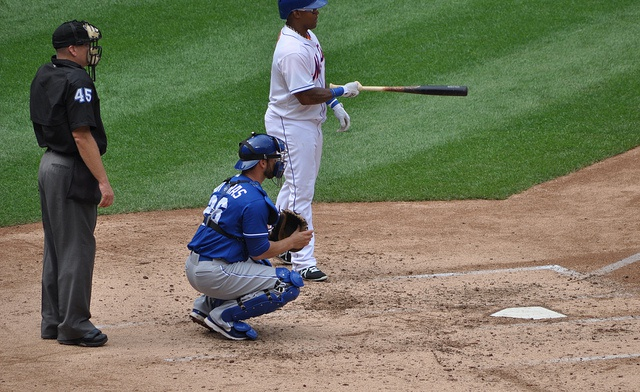Describe the objects in this image and their specific colors. I can see people in darkgreen, black, and gray tones, people in darkgreen, black, navy, gray, and darkgray tones, people in darkgreen, darkgray, lavender, and black tones, baseball bat in darkgreen, gray, black, and darkgray tones, and baseball glove in darkgreen, black, maroon, and gray tones in this image. 